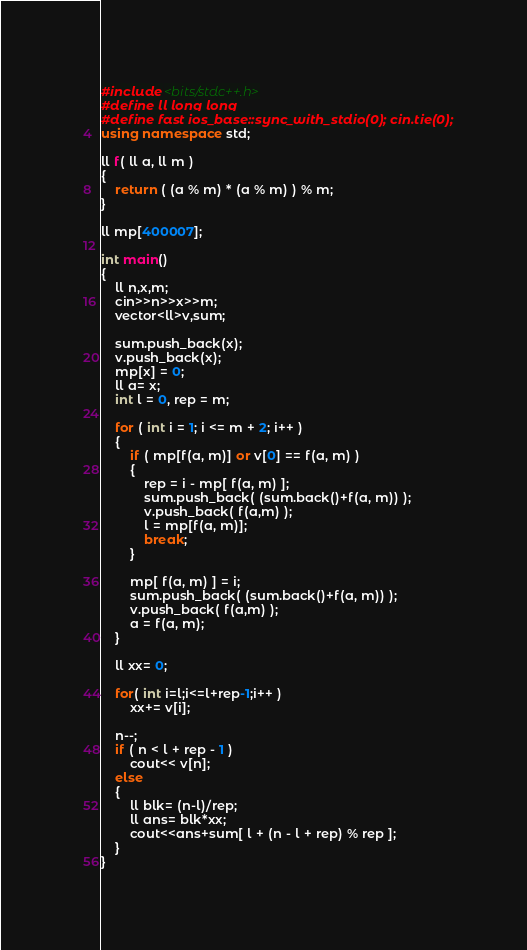<code> <loc_0><loc_0><loc_500><loc_500><_C++_>#include <bits/stdc++.h>
#define ll long long
#define fast ios_base::sync_with_stdio(0); cin.tie(0);
using namespace std;

ll f( ll a, ll m )
{
    return ( (a % m) * (a % m) ) % m;
}

ll mp[400007];

int main()
{
    ll n,x,m;
    cin>>n>>x>>m;
    vector<ll>v,sum;

    sum.push_back(x);
    v.push_back(x);
    mp[x] = 0;
    ll a= x;
    int l = 0, rep = m;

    for ( int i = 1; i <= m + 2; i++ )
    {
        if ( mp[f(a, m)] or v[0] == f(a, m) )
        {
            rep = i - mp[ f(a, m) ];
            sum.push_back( (sum.back()+f(a, m)) );
            v.push_back( f(a,m) );
            l = mp[f(a, m)];
            break;
        }

        mp[ f(a, m) ] = i;
        sum.push_back( (sum.back()+f(a, m)) );
        v.push_back( f(a,m) );
        a = f(a, m);
    }

    ll xx= 0;

    for( int i=l;i<=l+rep-1;i++ )
        xx+= v[i];

    n--;
    if ( n < l + rep - 1 )
        cout<< v[n];
    else
    {
        ll blk= (n-l)/rep;
        ll ans= blk*xx;
        cout<<ans+sum[ l + (n - l + rep) % rep ];
    }
}</code> 